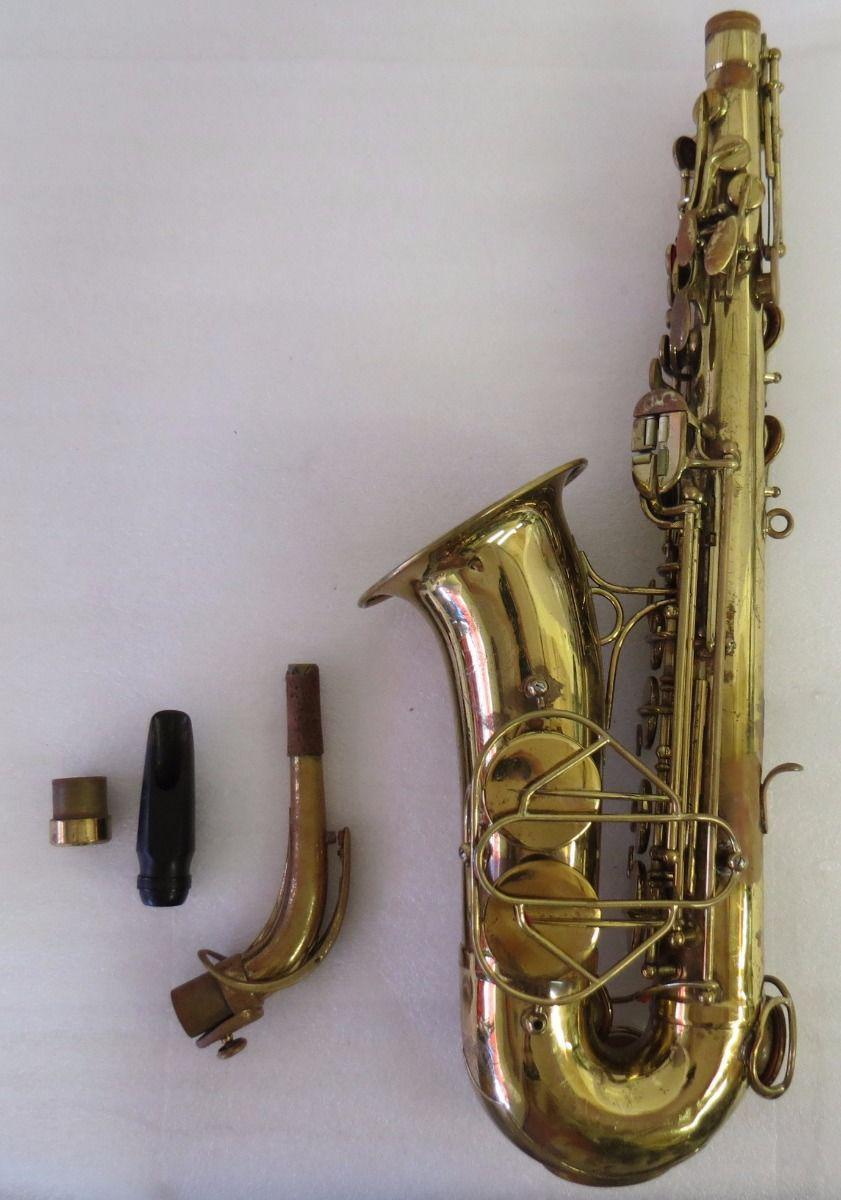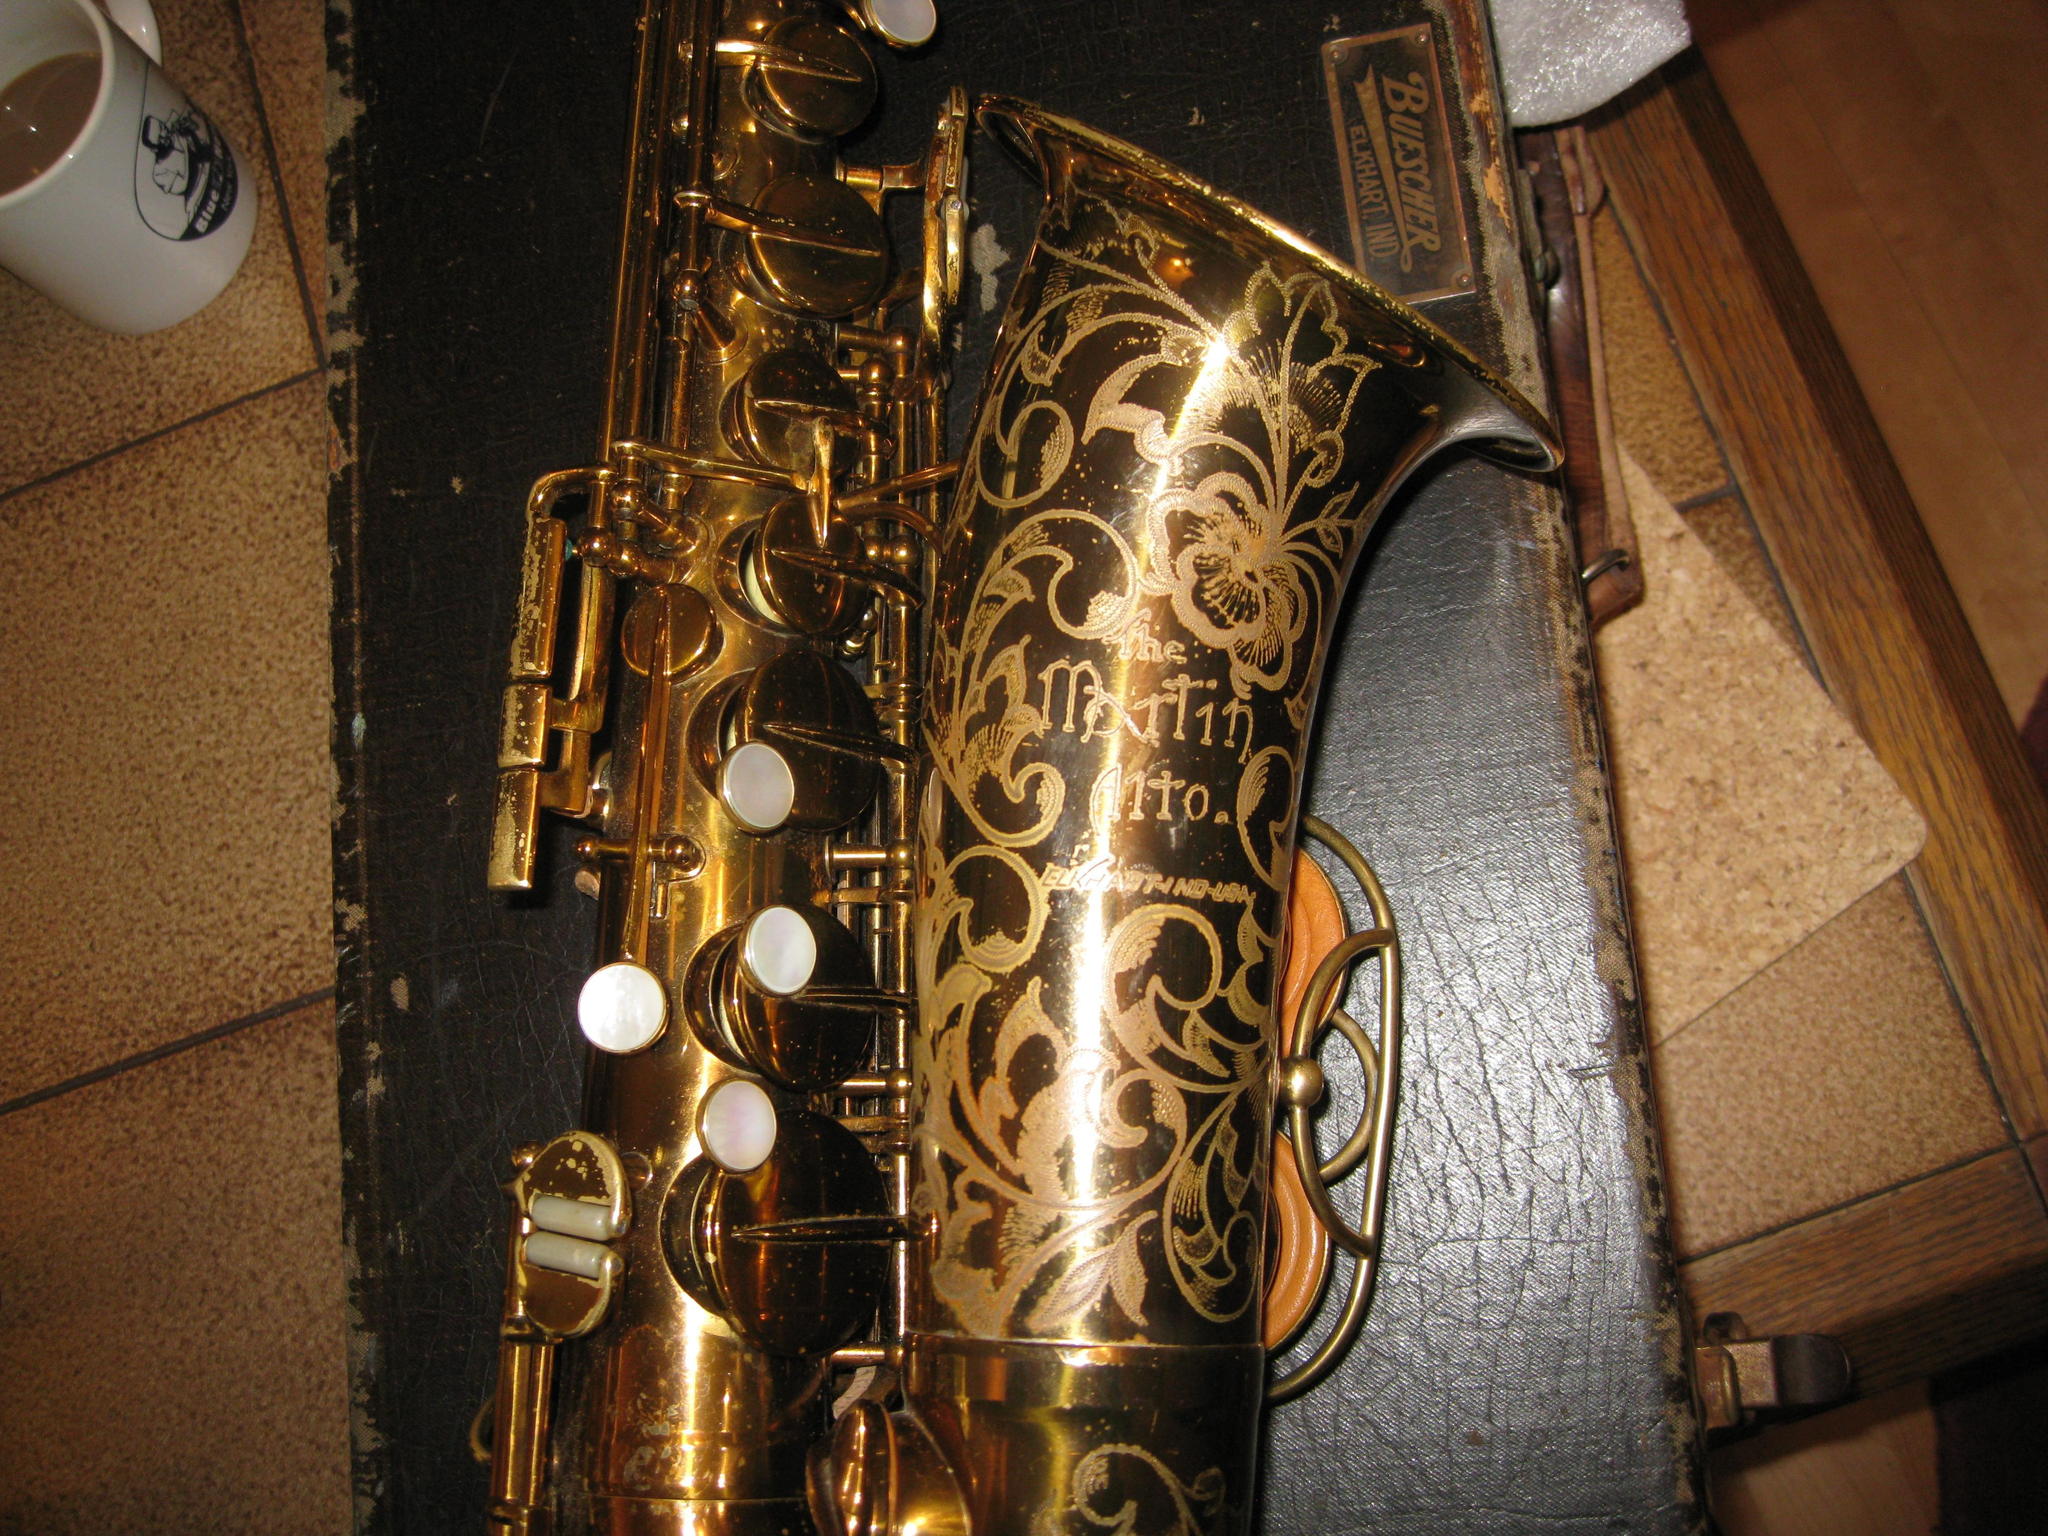The first image is the image on the left, the second image is the image on the right. Examine the images to the left and right. Is the description "One of the saxophones has etchings on it." accurate? Answer yes or no. Yes. The first image is the image on the left, the second image is the image on the right. Assess this claim about the two images: "The mouthpiece of the instrument is disconnected and laying next to the instrument in the left image.". Correct or not? Answer yes or no. Yes. 